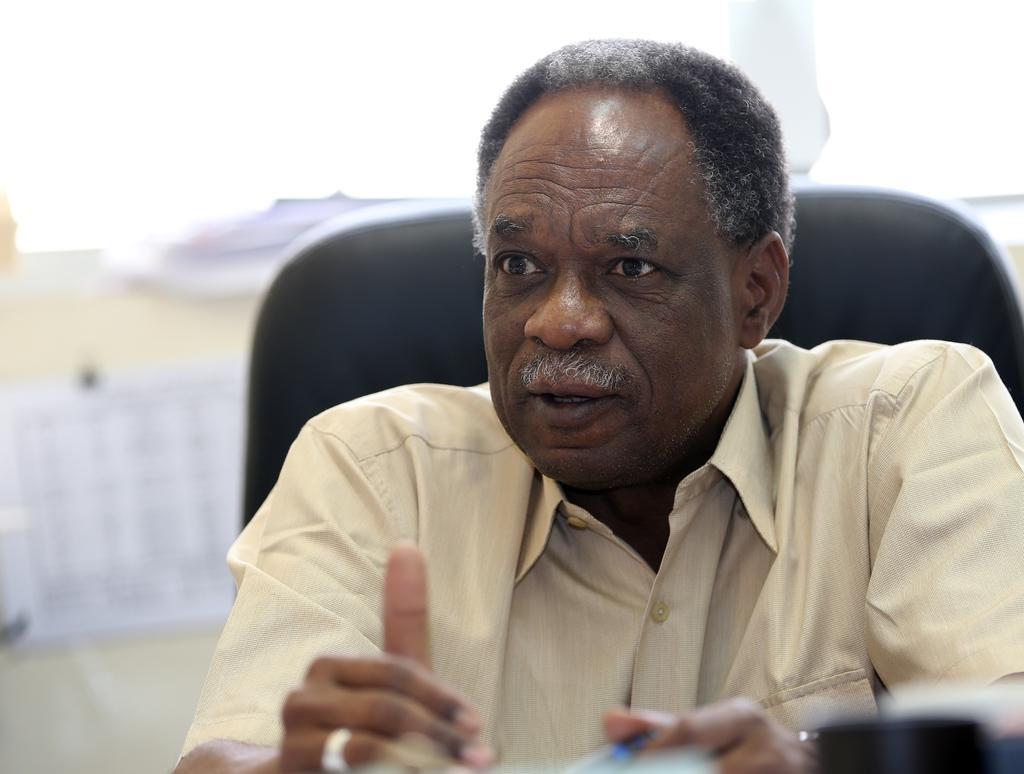In one or two sentences, can you explain what this image depicts? A man is talking, he wore shirt. 